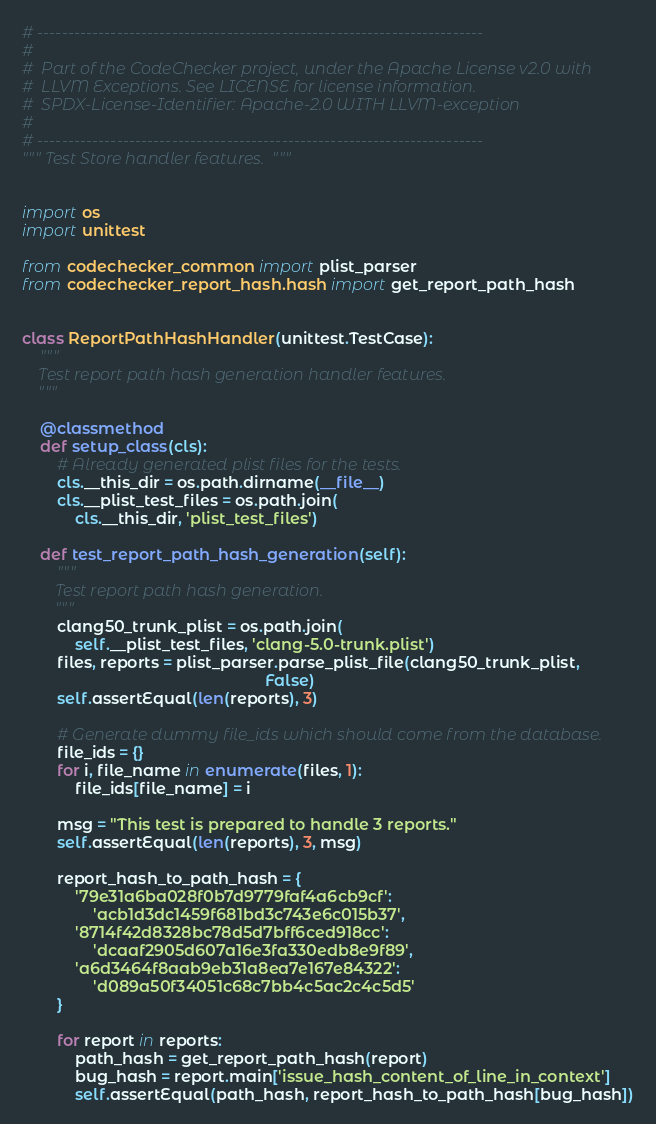<code> <loc_0><loc_0><loc_500><loc_500><_Python_># -------------------------------------------------------------------------
#
#  Part of the CodeChecker project, under the Apache License v2.0 with
#  LLVM Exceptions. See LICENSE for license information.
#  SPDX-License-Identifier: Apache-2.0 WITH LLVM-exception
#
# -------------------------------------------------------------------------
""" Test Store handler features.  """


import os
import unittest

from codechecker_common import plist_parser
from codechecker_report_hash.hash import get_report_path_hash


class ReportPathHashHandler(unittest.TestCase):
    """
    Test report path hash generation handler features.
    """

    @classmethod
    def setup_class(cls):
        # Already generated plist files for the tests.
        cls.__this_dir = os.path.dirname(__file__)
        cls.__plist_test_files = os.path.join(
            cls.__this_dir, 'plist_test_files')

    def test_report_path_hash_generation(self):
        """
        Test report path hash generation.
        """
        clang50_trunk_plist = os.path.join(
            self.__plist_test_files, 'clang-5.0-trunk.plist')
        files, reports = plist_parser.parse_plist_file(clang50_trunk_plist,
                                                       False)
        self.assertEqual(len(reports), 3)

        # Generate dummy file_ids which should come from the database.
        file_ids = {}
        for i, file_name in enumerate(files, 1):
            file_ids[file_name] = i

        msg = "This test is prepared to handle 3 reports."
        self.assertEqual(len(reports), 3, msg)

        report_hash_to_path_hash = {
            '79e31a6ba028f0b7d9779faf4a6cb9cf':
                'acb1d3dc1459f681bd3c743e6c015b37',
            '8714f42d8328bc78d5d7bff6ced918cc':
                'dcaaf2905d607a16e3fa330edb8e9f89',
            'a6d3464f8aab9eb31a8ea7e167e84322':
                'd089a50f34051c68c7bb4c5ac2c4c5d5'
        }

        for report in reports:
            path_hash = get_report_path_hash(report)
            bug_hash = report.main['issue_hash_content_of_line_in_context']
            self.assertEqual(path_hash, report_hash_to_path_hash[bug_hash])
</code> 